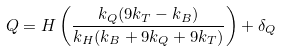<formula> <loc_0><loc_0><loc_500><loc_500>Q = H \left ( \frac { k _ { Q } ( 9 k _ { T } - k _ { B } ) } { k _ { H } ( k _ { B } + 9 k _ { Q } + 9 k _ { T } ) } \right ) + \delta _ { Q }</formula> 